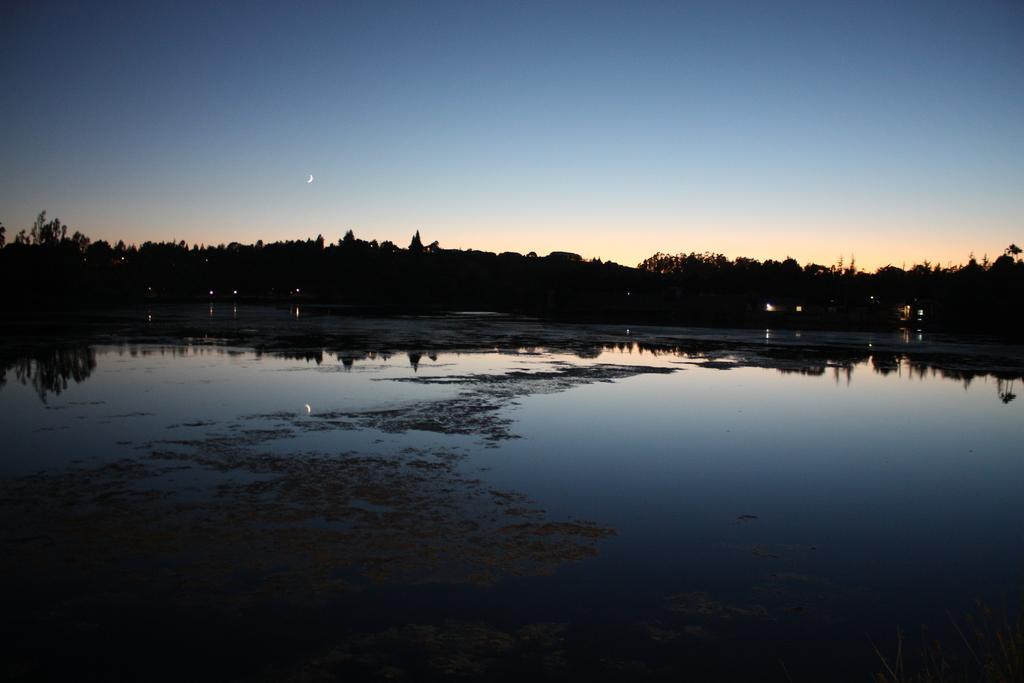How would you summarize this image in a sentence or two? In this image I can see the water. In the background I can see few vehicles, trees and the sky is in blue and white color. 